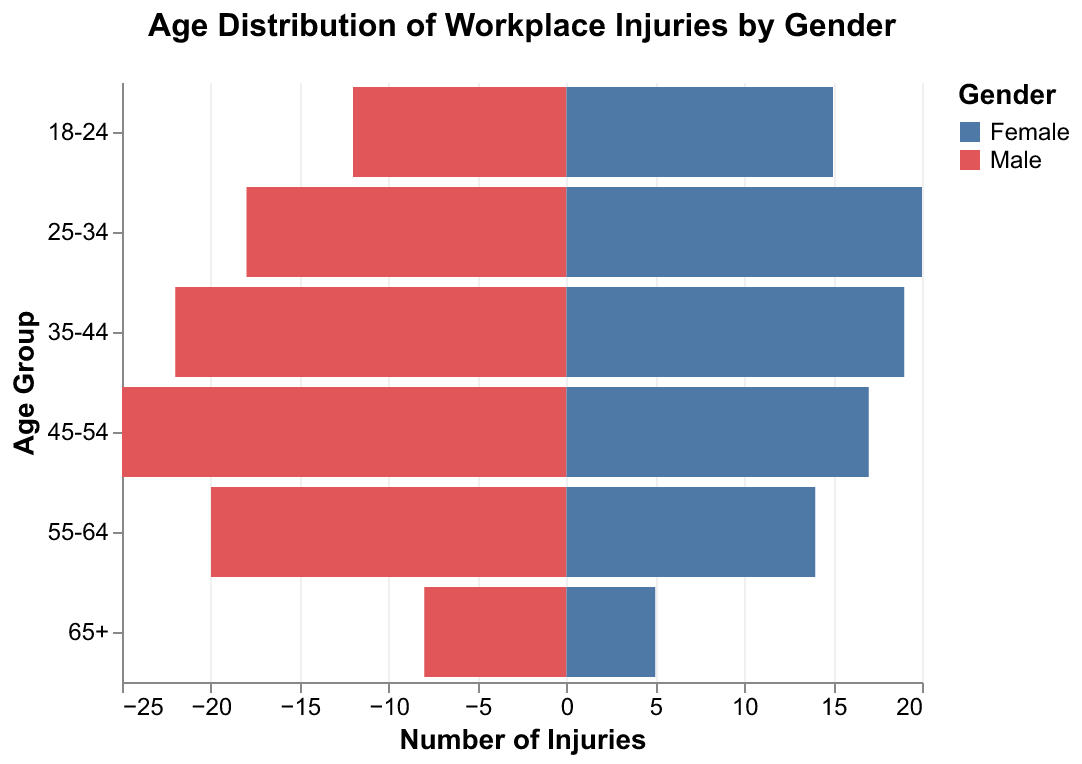What's the title of the figure? The title is usually placed at the top of the figure. Here, it clearly states the content of the data visualization.
Answer: Age Distribution of Workplace Injuries by Gender What are the age groups represented in the figure? The age groups are listed along the y-axis, which is labelled "Age Group". From top to bottom, the age groups are 18-24, 25-34, 35-44, 45-54, 55-64, and 65+.
Answer: 18-24, 25-34, 35-44, 45-54, 55-64, 65+ How many injuries occurred in the 45-54 age group for males? The bar representing the number of injuries for males in the 45-54 age group extends to the left from the y-axis. Count the units, and you will see that it extends to 25 units.
Answer: 25 Who has more injuries in the 25-34 age group, males or females? To determine this, compare the length of the bars for males and females in the 25-34 age group. The female bar is slightly longer.
Answer: Females Which gender experienced more injuries in the 55-64 age group? By comparing the lengths of the bars for males and females in the 55-64 age group, it is clear that the male bar extends further than the female bar.
Answer: Males What is the total number of injuries for the 65+ age group? To find the total, add the number of injuries for males and females in this age group. For males, there are 8 injuries, and for females, there are 5. The total is 8 + 5.
Answer: 13 What is the average number of injuries per age group for males? Add the number of injuries for males across all age groups and divide by the number of age groups: (12 + 18 + 22 + 25 + 20 + 8) / 6 = 105 / 6
Answer: 17.5 Which age group shows the highest total number of injuries combined for both genders? To find this, sum the injuries for males and females in each age group, then find the maximum. For 45-54: 25 + 17 = 42, which is the highest.
Answer: 45-54 Are there any age groups where females have more injuries than males? By comparing each pair of bars, it is evident that females have more injuries in the 18-24 and 25-34 age groups.
Answer: 18-24, 25-34 